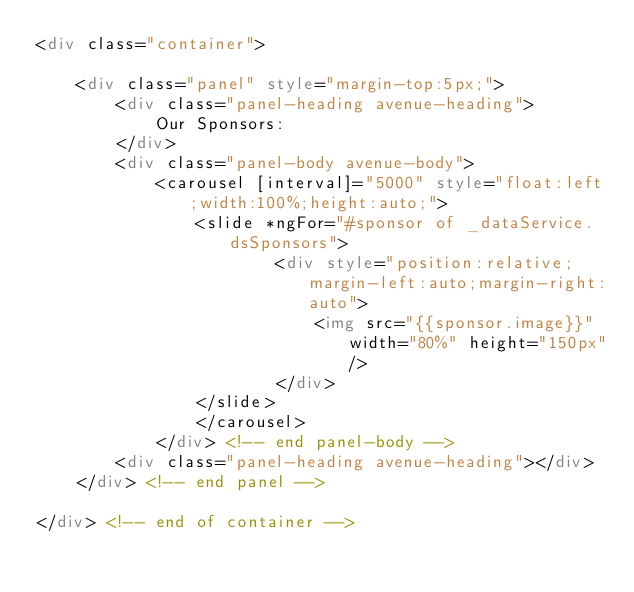Convert code to text. <code><loc_0><loc_0><loc_500><loc_500><_HTML_><div class="container">

    <div class="panel" style="margin-top:5px;">
        <div class="panel-heading avenue-heading">
            Our Sponsors:
        </div>
        <div class="panel-body avenue-body">
            <carousel [interval]="5000" style="float:left;width:100%;height:auto;">
                <slide *ngFor="#sponsor of _dataService.dsSponsors">
                        <div style="position:relative;margin-left:auto;margin-right:auto">
                            <img src="{{sponsor.image}}" width="80%" height="150px"/>
                        </div>
                </slide>
                </carousel>
            </div> <!-- end panel-body -->
        <div class="panel-heading avenue-heading"></div>
    </div> <!-- end panel -->

</div> <!-- end of container --></code> 